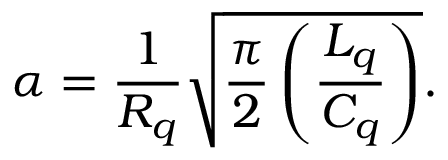Convert formula to latex. <formula><loc_0><loc_0><loc_500><loc_500>\alpha = \frac { 1 } { R _ { q } } \sqrt { \frac { \pi } { 2 } \left ( \frac { L _ { q } } { C _ { q } } \right ) } .</formula> 